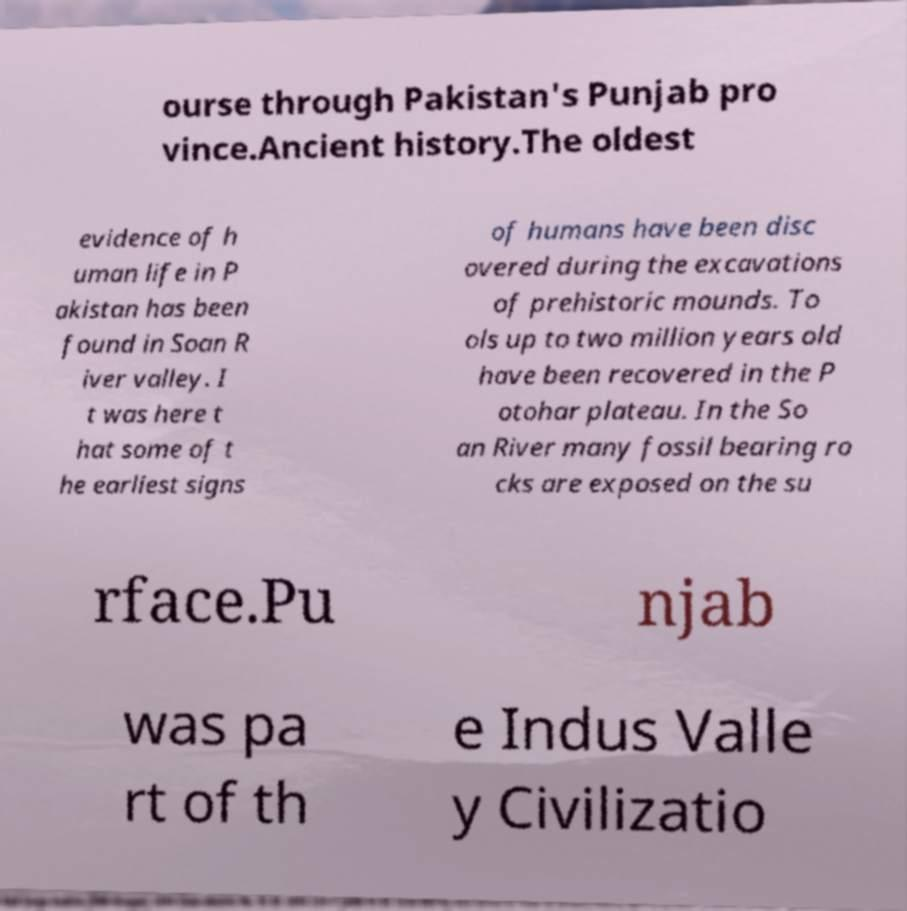I need the written content from this picture converted into text. Can you do that? ourse through Pakistan's Punjab pro vince.Ancient history.The oldest evidence of h uman life in P akistan has been found in Soan R iver valley. I t was here t hat some of t he earliest signs of humans have been disc overed during the excavations of prehistoric mounds. To ols up to two million years old have been recovered in the P otohar plateau. In the So an River many fossil bearing ro cks are exposed on the su rface.Pu njab was pa rt of th e Indus Valle y Civilizatio 